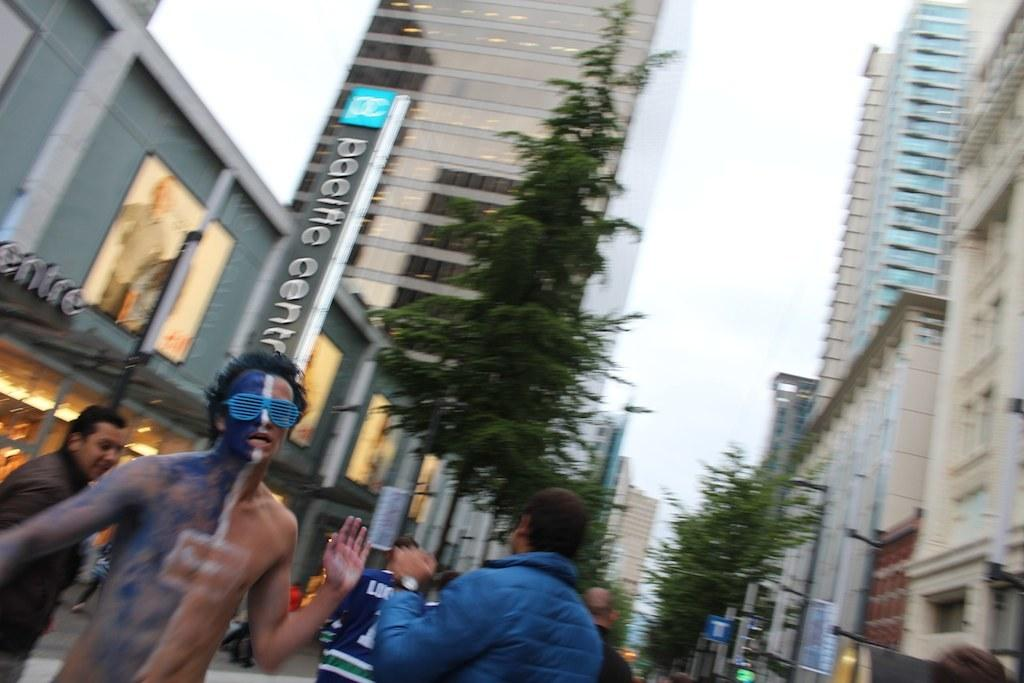How many people are in the image? There are persons in the image. Can you describe the appearance of one of the persons? One person is wearing paint on their body and is wearing spectacles. What type of structures can be seen in the image? There are buildings in the image. What natural elements are present in the image? There are trees in the image. What is visible in the background of the image? The sky is visible in the image. How much was the payment for the cloth used in the image? There is no payment or cloth mentioned in the image; it features persons, paint, spectacles, buildings, trees, and the sky. 